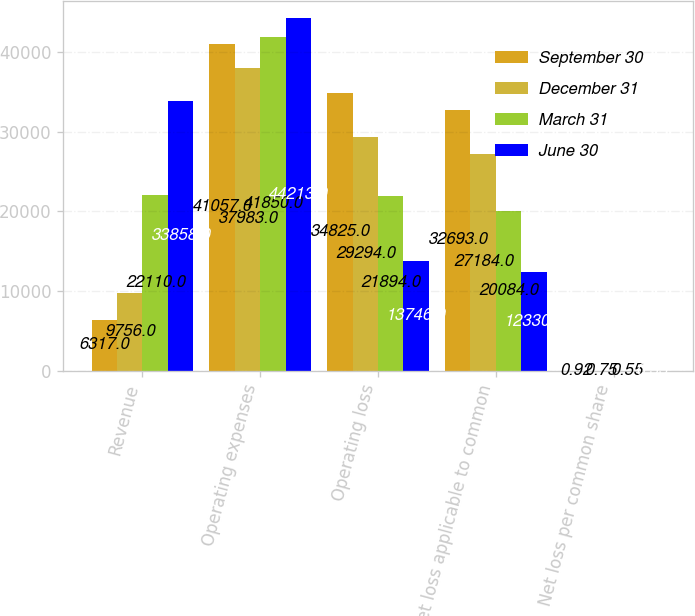Convert chart to OTSL. <chart><loc_0><loc_0><loc_500><loc_500><stacked_bar_chart><ecel><fcel>Revenue<fcel>Operating expenses<fcel>Operating loss<fcel>Net loss applicable to common<fcel>Net loss per common share<nl><fcel>September 30<fcel>6317<fcel>41057<fcel>34825<fcel>32693<fcel>0.92<nl><fcel>December 31<fcel>9756<fcel>37983<fcel>29294<fcel>27184<fcel>0.75<nl><fcel>March 31<fcel>22110<fcel>41850<fcel>21894<fcel>20084<fcel>0.55<nl><fcel>June 30<fcel>33858<fcel>44213<fcel>13746<fcel>12330<fcel>0.33<nl></chart> 